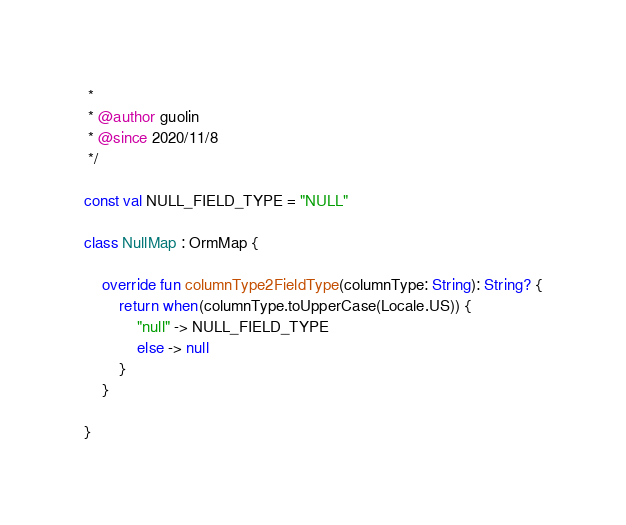Convert code to text. <code><loc_0><loc_0><loc_500><loc_500><_Kotlin_> *
 * @author guolin
 * @since 2020/11/8
 */

const val NULL_FIELD_TYPE = "NULL"

class NullMap : OrmMap {

    override fun columnType2FieldType(columnType: String): String? {
        return when(columnType.toUpperCase(Locale.US)) {
            "null" -> NULL_FIELD_TYPE
            else -> null
        }
    }

}</code> 